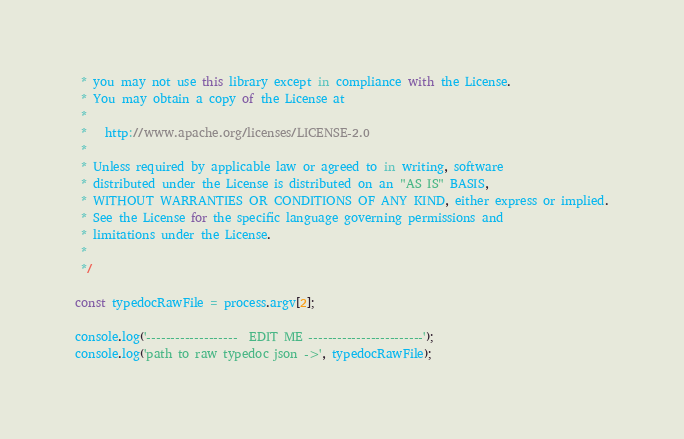<code> <loc_0><loc_0><loc_500><loc_500><_JavaScript_> * you may not use this library except in compliance with the License.
 * You may obtain a copy of the License at
 *
 *   http://www.apache.org/licenses/LICENSE-2.0
 *
 * Unless required by applicable law or agreed to in writing, software
 * distributed under the License is distributed on an "AS IS" BASIS,
 * WITHOUT WARRANTIES OR CONDITIONS OF ANY KIND, either express or implied.
 * See the License for the specific language governing permissions and
 * limitations under the License.
 *
 */

const typedocRawFile = process.argv[2];

console.log('-------------------  EDIT ME ------------------------');
console.log('path to raw typedoc json ->', typedocRawFile);</code> 